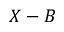Convert formula to latex. <formula><loc_0><loc_0><loc_500><loc_500>X - B</formula> 